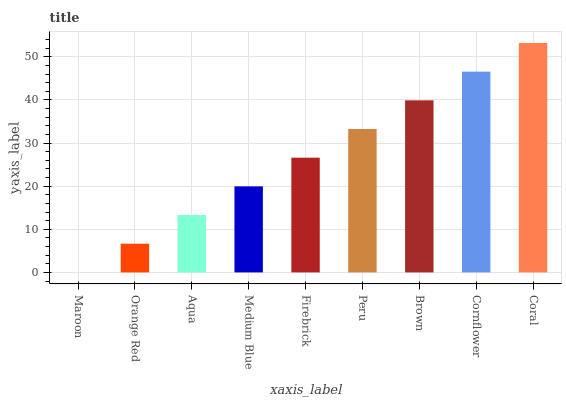Is Orange Red the minimum?
Answer yes or no. No. Is Orange Red the maximum?
Answer yes or no. No. Is Orange Red greater than Maroon?
Answer yes or no. Yes. Is Maroon less than Orange Red?
Answer yes or no. Yes. Is Maroon greater than Orange Red?
Answer yes or no. No. Is Orange Red less than Maroon?
Answer yes or no. No. Is Firebrick the high median?
Answer yes or no. Yes. Is Firebrick the low median?
Answer yes or no. Yes. Is Aqua the high median?
Answer yes or no. No. Is Peru the low median?
Answer yes or no. No. 